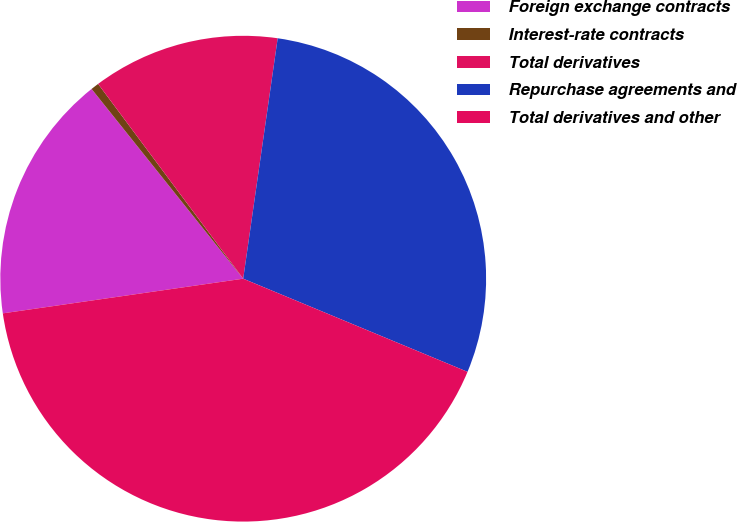Convert chart. <chart><loc_0><loc_0><loc_500><loc_500><pie_chart><fcel>Foreign exchange contracts<fcel>Interest-rate contracts<fcel>Total derivatives<fcel>Repurchase agreements and<fcel>Total derivatives and other<nl><fcel>16.55%<fcel>0.54%<fcel>12.46%<fcel>29.0%<fcel>41.46%<nl></chart> 